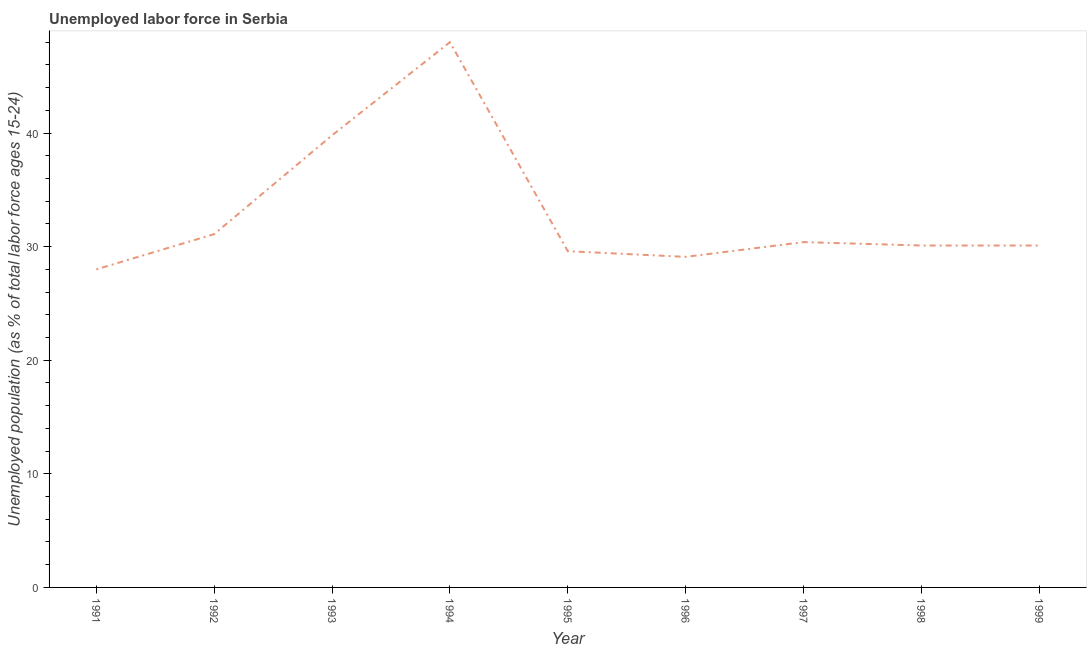What is the total unemployed youth population in 1999?
Provide a succinct answer. 30.1. Across all years, what is the minimum total unemployed youth population?
Provide a short and direct response. 28. In which year was the total unemployed youth population minimum?
Offer a very short reply. 1991. What is the sum of the total unemployed youth population?
Keep it short and to the point. 296.2. What is the average total unemployed youth population per year?
Offer a terse response. 32.91. What is the median total unemployed youth population?
Your answer should be compact. 30.1. In how many years, is the total unemployed youth population greater than 24 %?
Make the answer very short. 9. What is the ratio of the total unemployed youth population in 1996 to that in 1999?
Offer a terse response. 0.97. What is the difference between the highest and the second highest total unemployed youth population?
Make the answer very short. 8.2. Does the total unemployed youth population monotonically increase over the years?
Offer a terse response. No. How many years are there in the graph?
Your answer should be compact. 9. Does the graph contain grids?
Provide a short and direct response. No. What is the title of the graph?
Ensure brevity in your answer.  Unemployed labor force in Serbia. What is the label or title of the X-axis?
Ensure brevity in your answer.  Year. What is the label or title of the Y-axis?
Offer a very short reply. Unemployed population (as % of total labor force ages 15-24). What is the Unemployed population (as % of total labor force ages 15-24) of 1991?
Make the answer very short. 28. What is the Unemployed population (as % of total labor force ages 15-24) of 1992?
Provide a short and direct response. 31.1. What is the Unemployed population (as % of total labor force ages 15-24) in 1993?
Offer a very short reply. 39.8. What is the Unemployed population (as % of total labor force ages 15-24) of 1994?
Ensure brevity in your answer.  48. What is the Unemployed population (as % of total labor force ages 15-24) in 1995?
Provide a succinct answer. 29.6. What is the Unemployed population (as % of total labor force ages 15-24) of 1996?
Make the answer very short. 29.1. What is the Unemployed population (as % of total labor force ages 15-24) in 1997?
Give a very brief answer. 30.4. What is the Unemployed population (as % of total labor force ages 15-24) in 1998?
Ensure brevity in your answer.  30.1. What is the Unemployed population (as % of total labor force ages 15-24) of 1999?
Make the answer very short. 30.1. What is the difference between the Unemployed population (as % of total labor force ages 15-24) in 1991 and 1992?
Make the answer very short. -3.1. What is the difference between the Unemployed population (as % of total labor force ages 15-24) in 1991 and 1997?
Your answer should be very brief. -2.4. What is the difference between the Unemployed population (as % of total labor force ages 15-24) in 1991 and 1998?
Make the answer very short. -2.1. What is the difference between the Unemployed population (as % of total labor force ages 15-24) in 1991 and 1999?
Provide a short and direct response. -2.1. What is the difference between the Unemployed population (as % of total labor force ages 15-24) in 1992 and 1993?
Give a very brief answer. -8.7. What is the difference between the Unemployed population (as % of total labor force ages 15-24) in 1992 and 1994?
Provide a short and direct response. -16.9. What is the difference between the Unemployed population (as % of total labor force ages 15-24) in 1992 and 1996?
Offer a very short reply. 2. What is the difference between the Unemployed population (as % of total labor force ages 15-24) in 1992 and 1997?
Make the answer very short. 0.7. What is the difference between the Unemployed population (as % of total labor force ages 15-24) in 1993 and 1994?
Your response must be concise. -8.2. What is the difference between the Unemployed population (as % of total labor force ages 15-24) in 1993 and 1995?
Provide a succinct answer. 10.2. What is the difference between the Unemployed population (as % of total labor force ages 15-24) in 1994 and 1995?
Provide a succinct answer. 18.4. What is the difference between the Unemployed population (as % of total labor force ages 15-24) in 1994 and 1996?
Your answer should be very brief. 18.9. What is the difference between the Unemployed population (as % of total labor force ages 15-24) in 1995 and 1996?
Offer a very short reply. 0.5. What is the difference between the Unemployed population (as % of total labor force ages 15-24) in 1995 and 1997?
Offer a terse response. -0.8. What is the difference between the Unemployed population (as % of total labor force ages 15-24) in 1995 and 1998?
Give a very brief answer. -0.5. What is the difference between the Unemployed population (as % of total labor force ages 15-24) in 1995 and 1999?
Give a very brief answer. -0.5. What is the difference between the Unemployed population (as % of total labor force ages 15-24) in 1996 and 1998?
Offer a terse response. -1. What is the difference between the Unemployed population (as % of total labor force ages 15-24) in 1997 and 1998?
Provide a succinct answer. 0.3. What is the ratio of the Unemployed population (as % of total labor force ages 15-24) in 1991 to that in 1993?
Make the answer very short. 0.7. What is the ratio of the Unemployed population (as % of total labor force ages 15-24) in 1991 to that in 1994?
Your answer should be very brief. 0.58. What is the ratio of the Unemployed population (as % of total labor force ages 15-24) in 1991 to that in 1995?
Keep it short and to the point. 0.95. What is the ratio of the Unemployed population (as % of total labor force ages 15-24) in 1991 to that in 1997?
Keep it short and to the point. 0.92. What is the ratio of the Unemployed population (as % of total labor force ages 15-24) in 1991 to that in 1998?
Keep it short and to the point. 0.93. What is the ratio of the Unemployed population (as % of total labor force ages 15-24) in 1991 to that in 1999?
Ensure brevity in your answer.  0.93. What is the ratio of the Unemployed population (as % of total labor force ages 15-24) in 1992 to that in 1993?
Provide a succinct answer. 0.78. What is the ratio of the Unemployed population (as % of total labor force ages 15-24) in 1992 to that in 1994?
Provide a succinct answer. 0.65. What is the ratio of the Unemployed population (as % of total labor force ages 15-24) in 1992 to that in 1995?
Provide a succinct answer. 1.05. What is the ratio of the Unemployed population (as % of total labor force ages 15-24) in 1992 to that in 1996?
Keep it short and to the point. 1.07. What is the ratio of the Unemployed population (as % of total labor force ages 15-24) in 1992 to that in 1997?
Your answer should be very brief. 1.02. What is the ratio of the Unemployed population (as % of total labor force ages 15-24) in 1992 to that in 1998?
Your answer should be very brief. 1.03. What is the ratio of the Unemployed population (as % of total labor force ages 15-24) in 1992 to that in 1999?
Give a very brief answer. 1.03. What is the ratio of the Unemployed population (as % of total labor force ages 15-24) in 1993 to that in 1994?
Your answer should be very brief. 0.83. What is the ratio of the Unemployed population (as % of total labor force ages 15-24) in 1993 to that in 1995?
Your response must be concise. 1.34. What is the ratio of the Unemployed population (as % of total labor force ages 15-24) in 1993 to that in 1996?
Keep it short and to the point. 1.37. What is the ratio of the Unemployed population (as % of total labor force ages 15-24) in 1993 to that in 1997?
Your response must be concise. 1.31. What is the ratio of the Unemployed population (as % of total labor force ages 15-24) in 1993 to that in 1998?
Provide a short and direct response. 1.32. What is the ratio of the Unemployed population (as % of total labor force ages 15-24) in 1993 to that in 1999?
Offer a very short reply. 1.32. What is the ratio of the Unemployed population (as % of total labor force ages 15-24) in 1994 to that in 1995?
Give a very brief answer. 1.62. What is the ratio of the Unemployed population (as % of total labor force ages 15-24) in 1994 to that in 1996?
Make the answer very short. 1.65. What is the ratio of the Unemployed population (as % of total labor force ages 15-24) in 1994 to that in 1997?
Ensure brevity in your answer.  1.58. What is the ratio of the Unemployed population (as % of total labor force ages 15-24) in 1994 to that in 1998?
Your answer should be very brief. 1.59. What is the ratio of the Unemployed population (as % of total labor force ages 15-24) in 1994 to that in 1999?
Offer a terse response. 1.59. What is the ratio of the Unemployed population (as % of total labor force ages 15-24) in 1995 to that in 1996?
Provide a short and direct response. 1.02. What is the ratio of the Unemployed population (as % of total labor force ages 15-24) in 1995 to that in 1997?
Offer a very short reply. 0.97. What is the ratio of the Unemployed population (as % of total labor force ages 15-24) in 1995 to that in 1998?
Provide a succinct answer. 0.98. What is the ratio of the Unemployed population (as % of total labor force ages 15-24) in 1996 to that in 1997?
Provide a succinct answer. 0.96. What is the ratio of the Unemployed population (as % of total labor force ages 15-24) in 1996 to that in 1999?
Your answer should be compact. 0.97. What is the ratio of the Unemployed population (as % of total labor force ages 15-24) in 1997 to that in 1998?
Keep it short and to the point. 1.01. 